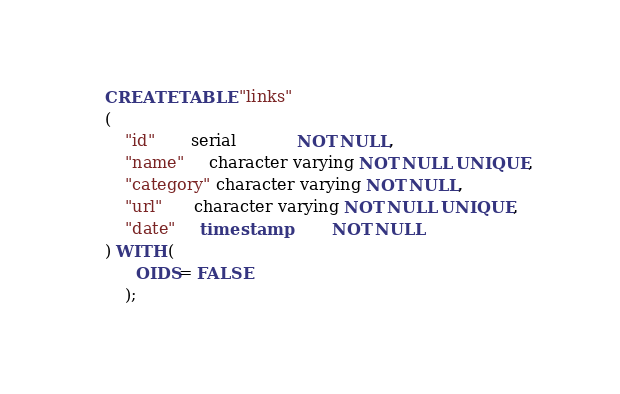Convert code to text. <code><loc_0><loc_0><loc_500><loc_500><_SQL_>CREATE TABLE "links"
(
    "id"       serial            NOT NULL,
    "name"     character varying NOT NULL UNIQUE,
    "category" character varying NOT NULL,
    "url"      character varying NOT NULL UNIQUE,
    "date"     timestamp         NOT NULL
) WITH (
      OIDS= FALSE
    );</code> 